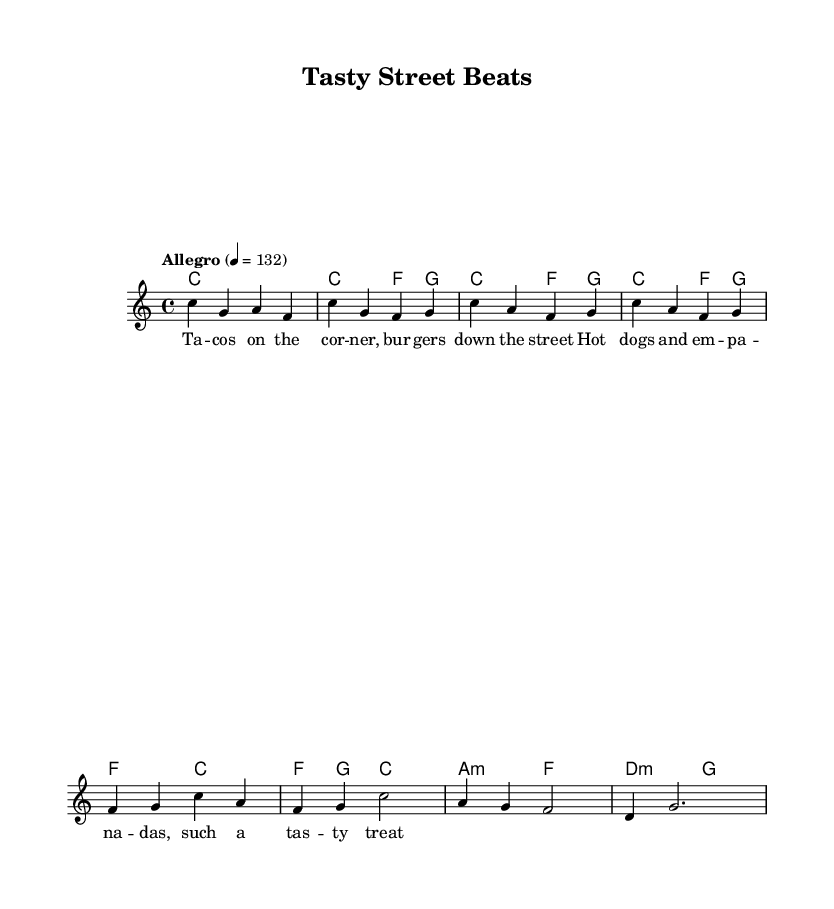What is the key signature of this music? The key signature is indicated by the absence of any sharps or flats, which represents C major.
Answer: C major What is the time signature of this piece? The time signature is found at the beginning of the score and shows that each measure contains four beats, denoted by the 4/4 indication.
Answer: 4/4 What is the tempo marking for the music? The tempo marking "Allegro" indicates a fast pace, and the number 132 specifies the beats per minute, which can be seen at the start of the score.
Answer: Allegro 4 = 132 How many measures are there in the chorus section? By counting the measures in the designated chorus section of the music, it can be seen that there are four measures total.
Answer: 4 What type of rhythm is used throughout the song? The rhythm primarily consists of quarter notes and half notes, as observed in both the melody and harmony sections of the score.
Answer: Syncopated What is the primary theme of the lyrics in the verse? The lyrics describe various fast food items like burgers and hot dogs, emphasizing delightful street snacks and the enjoyment of food.
Answer: Enjoying street snacks What is the harmonic progression for the chorus? The harmonic progression in the chorus shows a pattern of F major, C major, returning to F major, and resolving to C major, clearly outlined in the chord changes.
Answer: F, C, F, C 